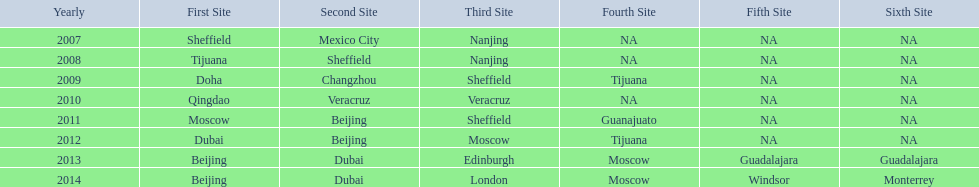What years had the most venues? 2013, 2014. 